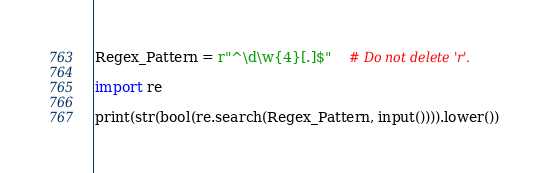<code> <loc_0><loc_0><loc_500><loc_500><_Python_>Regex_Pattern = r"^\d\w{4}[.]$"	# Do not delete 'r'.

import re

print(str(bool(re.search(Regex_Pattern, input()))).lower())
</code> 